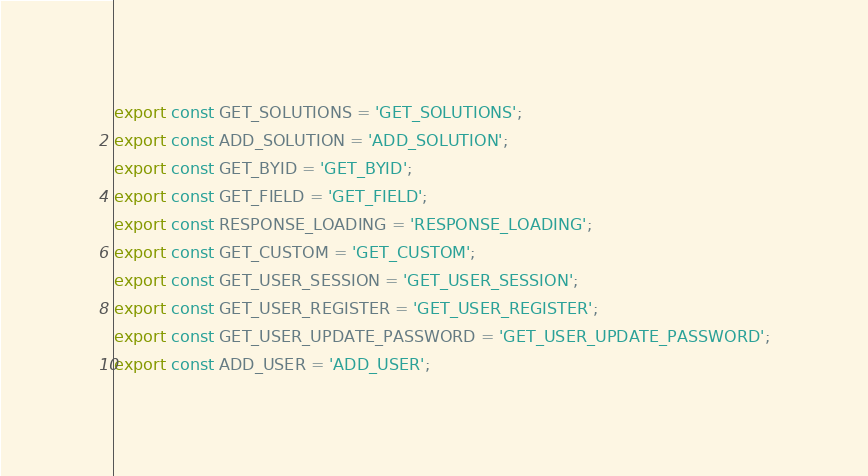<code> <loc_0><loc_0><loc_500><loc_500><_JavaScript_>export const GET_SOLUTIONS = 'GET_SOLUTIONS';
export const ADD_SOLUTION = 'ADD_SOLUTION';
export const GET_BYID = 'GET_BYID';
export const GET_FIELD = 'GET_FIELD';
export const RESPONSE_LOADING = 'RESPONSE_LOADING';
export const GET_CUSTOM = 'GET_CUSTOM';
export const GET_USER_SESSION = 'GET_USER_SESSION';
export const GET_USER_REGISTER = 'GET_USER_REGISTER';
export const GET_USER_UPDATE_PASSWORD = 'GET_USER_UPDATE_PASSWORD';
export const ADD_USER = 'ADD_USER';
</code> 